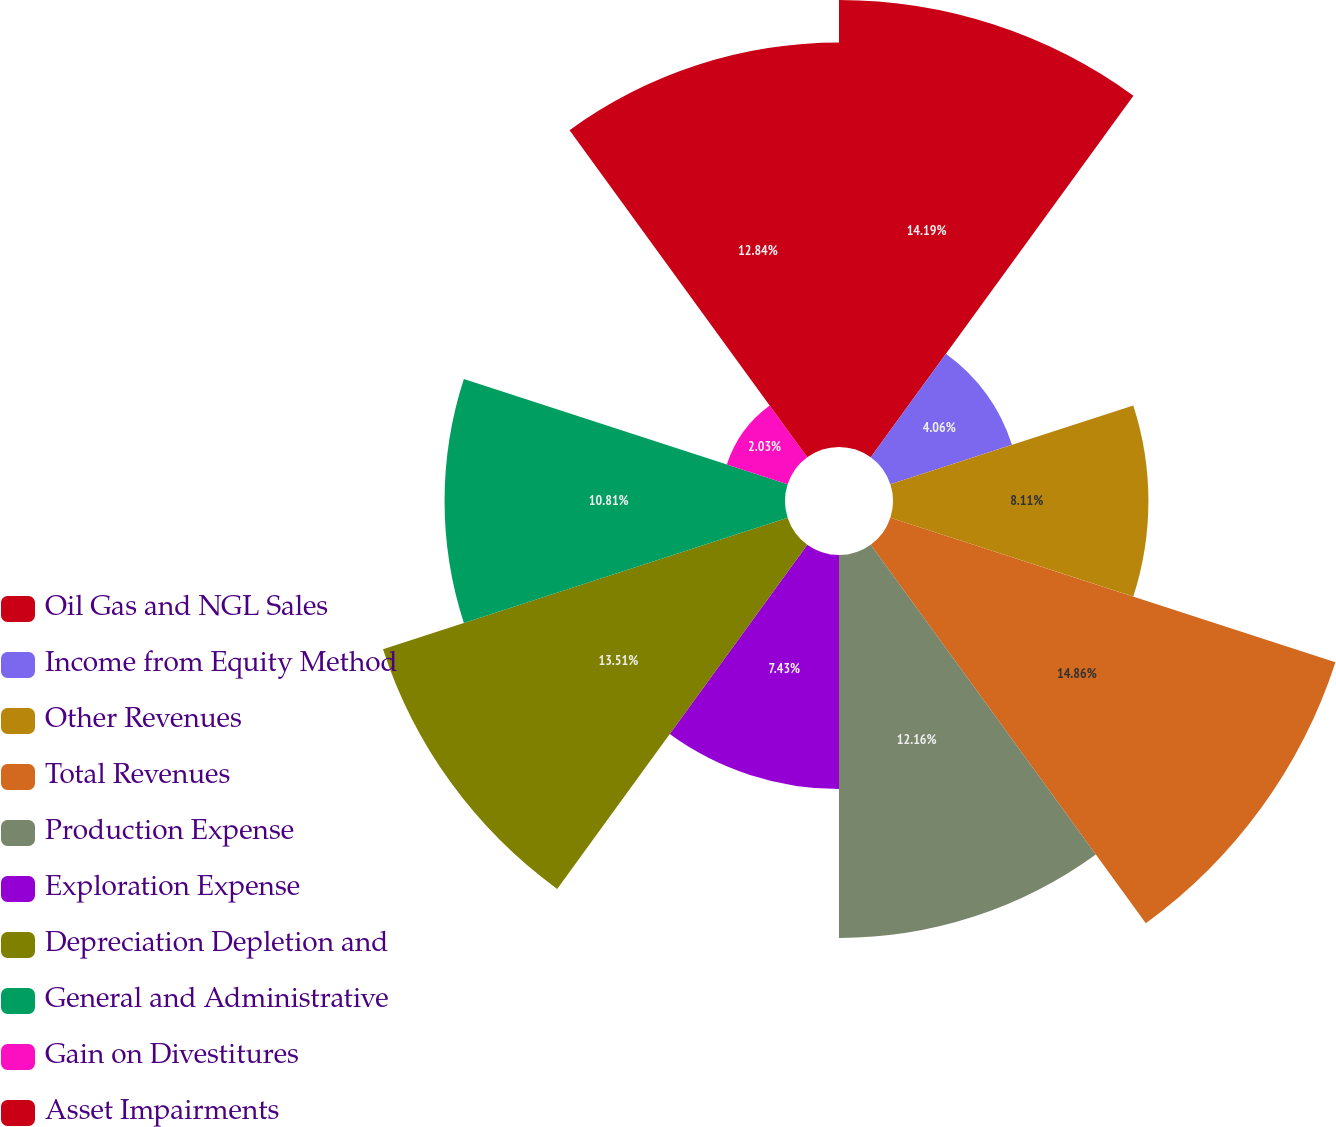Convert chart. <chart><loc_0><loc_0><loc_500><loc_500><pie_chart><fcel>Oil Gas and NGL Sales<fcel>Income from Equity Method<fcel>Other Revenues<fcel>Total Revenues<fcel>Production Expense<fcel>Exploration Expense<fcel>Depreciation Depletion and<fcel>General and Administrative<fcel>Gain on Divestitures<fcel>Asset Impairments<nl><fcel>14.19%<fcel>4.06%<fcel>8.11%<fcel>14.86%<fcel>12.16%<fcel>7.43%<fcel>13.51%<fcel>10.81%<fcel>2.03%<fcel>12.84%<nl></chart> 